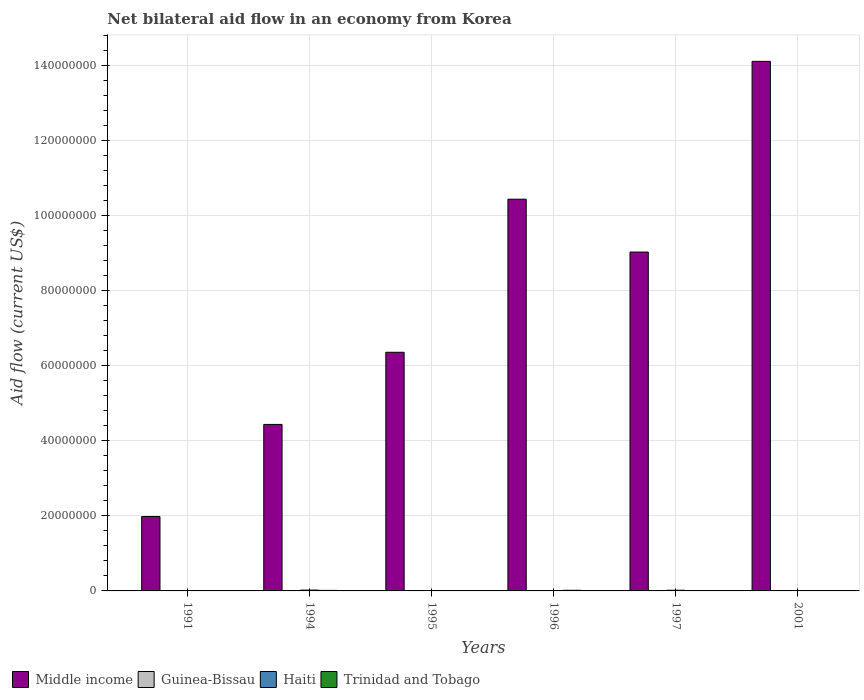How many different coloured bars are there?
Offer a terse response. 4. Are the number of bars per tick equal to the number of legend labels?
Provide a succinct answer. Yes. Are the number of bars on each tick of the X-axis equal?
Your answer should be very brief. Yes. How many bars are there on the 4th tick from the left?
Your answer should be very brief. 4. How many bars are there on the 5th tick from the right?
Offer a very short reply. 4. What is the label of the 3rd group of bars from the left?
Keep it short and to the point. 1995. In how many cases, is the number of bars for a given year not equal to the number of legend labels?
Provide a short and direct response. 0. What is the net bilateral aid flow in Middle income in 2001?
Provide a short and direct response. 1.41e+08. Across all years, what is the minimum net bilateral aid flow in Trinidad and Tobago?
Your response must be concise. 2.00e+04. In which year was the net bilateral aid flow in Middle income minimum?
Offer a terse response. 1991. What is the total net bilateral aid flow in Guinea-Bissau in the graph?
Give a very brief answer. 3.30e+05. What is the difference between the net bilateral aid flow in Trinidad and Tobago in 1994 and that in 1996?
Your response must be concise. -3.00e+04. What is the difference between the net bilateral aid flow in Middle income in 1996 and the net bilateral aid flow in Haiti in 1994?
Your answer should be very brief. 1.04e+08. What is the average net bilateral aid flow in Haiti per year?
Give a very brief answer. 1.08e+05. In the year 1991, what is the difference between the net bilateral aid flow in Middle income and net bilateral aid flow in Trinidad and Tobago?
Your answer should be compact. 1.97e+07. What is the ratio of the net bilateral aid flow in Guinea-Bissau in 1995 to that in 1996?
Your answer should be very brief. 0.62. Is the difference between the net bilateral aid flow in Middle income in 1991 and 2001 greater than the difference between the net bilateral aid flow in Trinidad and Tobago in 1991 and 2001?
Your response must be concise. No. What is the difference between the highest and the second highest net bilateral aid flow in Haiti?
Offer a very short reply. 4.00e+04. In how many years, is the net bilateral aid flow in Trinidad and Tobago greater than the average net bilateral aid flow in Trinidad and Tobago taken over all years?
Ensure brevity in your answer.  3. What does the 2nd bar from the left in 1995 represents?
Keep it short and to the point. Guinea-Bissau. What does the 2nd bar from the right in 1995 represents?
Provide a succinct answer. Haiti. How are the legend labels stacked?
Make the answer very short. Horizontal. What is the title of the graph?
Your answer should be very brief. Net bilateral aid flow in an economy from Korea. Does "Kiribati" appear as one of the legend labels in the graph?
Keep it short and to the point. No. What is the Aid flow (current US$) of Middle income in 1991?
Offer a terse response. 1.98e+07. What is the Aid flow (current US$) in Haiti in 1991?
Give a very brief answer. 10000. What is the Aid flow (current US$) in Middle income in 1994?
Offer a terse response. 4.44e+07. What is the Aid flow (current US$) in Guinea-Bissau in 1994?
Offer a very short reply. 5.00e+04. What is the Aid flow (current US$) of Trinidad and Tobago in 1994?
Provide a succinct answer. 1.40e+05. What is the Aid flow (current US$) of Middle income in 1995?
Give a very brief answer. 6.36e+07. What is the Aid flow (current US$) in Trinidad and Tobago in 1995?
Your answer should be compact. 1.00e+05. What is the Aid flow (current US$) in Middle income in 1996?
Ensure brevity in your answer.  1.04e+08. What is the Aid flow (current US$) of Guinea-Bissau in 1996?
Provide a succinct answer. 8.00e+04. What is the Aid flow (current US$) in Haiti in 1996?
Your response must be concise. 1.00e+05. What is the Aid flow (current US$) of Middle income in 1997?
Offer a very short reply. 9.03e+07. What is the Aid flow (current US$) of Trinidad and Tobago in 1997?
Provide a short and direct response. 9.00e+04. What is the Aid flow (current US$) of Middle income in 2001?
Your answer should be compact. 1.41e+08. What is the Aid flow (current US$) of Guinea-Bissau in 2001?
Offer a very short reply. 4.00e+04. Across all years, what is the maximum Aid flow (current US$) of Middle income?
Keep it short and to the point. 1.41e+08. Across all years, what is the minimum Aid flow (current US$) of Middle income?
Make the answer very short. 1.98e+07. Across all years, what is the minimum Aid flow (current US$) in Haiti?
Make the answer very short. 10000. What is the total Aid flow (current US$) in Middle income in the graph?
Offer a very short reply. 4.64e+08. What is the total Aid flow (current US$) in Guinea-Bissau in the graph?
Your response must be concise. 3.30e+05. What is the total Aid flow (current US$) in Haiti in the graph?
Your answer should be compact. 6.50e+05. What is the total Aid flow (current US$) of Trinidad and Tobago in the graph?
Ensure brevity in your answer.  6.30e+05. What is the difference between the Aid flow (current US$) of Middle income in 1991 and that in 1994?
Offer a terse response. -2.46e+07. What is the difference between the Aid flow (current US$) of Haiti in 1991 and that in 1994?
Keep it short and to the point. -2.10e+05. What is the difference between the Aid flow (current US$) in Trinidad and Tobago in 1991 and that in 1994?
Provide a succinct answer. -3.00e+04. What is the difference between the Aid flow (current US$) in Middle income in 1991 and that in 1995?
Your response must be concise. -4.38e+07. What is the difference between the Aid flow (current US$) in Guinea-Bissau in 1991 and that in 1995?
Offer a terse response. 3.00e+04. What is the difference between the Aid flow (current US$) in Trinidad and Tobago in 1991 and that in 1995?
Offer a very short reply. 10000. What is the difference between the Aid flow (current US$) in Middle income in 1991 and that in 1996?
Ensure brevity in your answer.  -8.46e+07. What is the difference between the Aid flow (current US$) in Guinea-Bissau in 1991 and that in 1996?
Provide a short and direct response. 0. What is the difference between the Aid flow (current US$) of Haiti in 1991 and that in 1996?
Provide a succinct answer. -9.00e+04. What is the difference between the Aid flow (current US$) in Trinidad and Tobago in 1991 and that in 1996?
Provide a short and direct response. -6.00e+04. What is the difference between the Aid flow (current US$) in Middle income in 1991 and that in 1997?
Give a very brief answer. -7.05e+07. What is the difference between the Aid flow (current US$) of Guinea-Bissau in 1991 and that in 1997?
Give a very brief answer. 5.00e+04. What is the difference between the Aid flow (current US$) of Middle income in 1991 and that in 2001?
Give a very brief answer. -1.21e+08. What is the difference between the Aid flow (current US$) in Guinea-Bissau in 1991 and that in 2001?
Keep it short and to the point. 4.00e+04. What is the difference between the Aid flow (current US$) in Haiti in 1991 and that in 2001?
Offer a very short reply. -3.00e+04. What is the difference between the Aid flow (current US$) of Middle income in 1994 and that in 1995?
Your answer should be compact. -1.92e+07. What is the difference between the Aid flow (current US$) of Trinidad and Tobago in 1994 and that in 1995?
Offer a very short reply. 4.00e+04. What is the difference between the Aid flow (current US$) in Middle income in 1994 and that in 1996?
Your answer should be very brief. -6.00e+07. What is the difference between the Aid flow (current US$) of Guinea-Bissau in 1994 and that in 1996?
Provide a short and direct response. -3.00e+04. What is the difference between the Aid flow (current US$) in Middle income in 1994 and that in 1997?
Make the answer very short. -4.59e+07. What is the difference between the Aid flow (current US$) in Guinea-Bissau in 1994 and that in 1997?
Your answer should be very brief. 2.00e+04. What is the difference between the Aid flow (current US$) in Trinidad and Tobago in 1994 and that in 1997?
Your answer should be very brief. 5.00e+04. What is the difference between the Aid flow (current US$) of Middle income in 1994 and that in 2001?
Provide a succinct answer. -9.68e+07. What is the difference between the Aid flow (current US$) of Haiti in 1994 and that in 2001?
Offer a very short reply. 1.80e+05. What is the difference between the Aid flow (current US$) of Middle income in 1995 and that in 1996?
Provide a succinct answer. -4.08e+07. What is the difference between the Aid flow (current US$) in Guinea-Bissau in 1995 and that in 1996?
Offer a very short reply. -3.00e+04. What is the difference between the Aid flow (current US$) in Trinidad and Tobago in 1995 and that in 1996?
Ensure brevity in your answer.  -7.00e+04. What is the difference between the Aid flow (current US$) in Middle income in 1995 and that in 1997?
Provide a short and direct response. -2.67e+07. What is the difference between the Aid flow (current US$) of Haiti in 1995 and that in 1997?
Provide a short and direct response. -8.00e+04. What is the difference between the Aid flow (current US$) in Middle income in 1995 and that in 2001?
Give a very brief answer. -7.75e+07. What is the difference between the Aid flow (current US$) of Guinea-Bissau in 1995 and that in 2001?
Offer a very short reply. 10000. What is the difference between the Aid flow (current US$) in Haiti in 1995 and that in 2001?
Make the answer very short. 6.00e+04. What is the difference between the Aid flow (current US$) in Middle income in 1996 and that in 1997?
Offer a very short reply. 1.41e+07. What is the difference between the Aid flow (current US$) of Haiti in 1996 and that in 1997?
Give a very brief answer. -8.00e+04. What is the difference between the Aid flow (current US$) of Trinidad and Tobago in 1996 and that in 1997?
Provide a short and direct response. 8.00e+04. What is the difference between the Aid flow (current US$) of Middle income in 1996 and that in 2001?
Provide a short and direct response. -3.67e+07. What is the difference between the Aid flow (current US$) in Guinea-Bissau in 1996 and that in 2001?
Offer a very short reply. 4.00e+04. What is the difference between the Aid flow (current US$) of Haiti in 1996 and that in 2001?
Provide a succinct answer. 6.00e+04. What is the difference between the Aid flow (current US$) of Trinidad and Tobago in 1996 and that in 2001?
Make the answer very short. 1.50e+05. What is the difference between the Aid flow (current US$) in Middle income in 1997 and that in 2001?
Ensure brevity in your answer.  -5.08e+07. What is the difference between the Aid flow (current US$) in Middle income in 1991 and the Aid flow (current US$) in Guinea-Bissau in 1994?
Make the answer very short. 1.98e+07. What is the difference between the Aid flow (current US$) of Middle income in 1991 and the Aid flow (current US$) of Haiti in 1994?
Make the answer very short. 1.96e+07. What is the difference between the Aid flow (current US$) of Middle income in 1991 and the Aid flow (current US$) of Trinidad and Tobago in 1994?
Your response must be concise. 1.97e+07. What is the difference between the Aid flow (current US$) of Guinea-Bissau in 1991 and the Aid flow (current US$) of Trinidad and Tobago in 1994?
Your answer should be very brief. -6.00e+04. What is the difference between the Aid flow (current US$) in Middle income in 1991 and the Aid flow (current US$) in Guinea-Bissau in 1995?
Your response must be concise. 1.98e+07. What is the difference between the Aid flow (current US$) of Middle income in 1991 and the Aid flow (current US$) of Haiti in 1995?
Make the answer very short. 1.97e+07. What is the difference between the Aid flow (current US$) of Middle income in 1991 and the Aid flow (current US$) of Trinidad and Tobago in 1995?
Your answer should be compact. 1.97e+07. What is the difference between the Aid flow (current US$) of Guinea-Bissau in 1991 and the Aid flow (current US$) of Trinidad and Tobago in 1995?
Your answer should be very brief. -2.00e+04. What is the difference between the Aid flow (current US$) in Haiti in 1991 and the Aid flow (current US$) in Trinidad and Tobago in 1995?
Provide a short and direct response. -9.00e+04. What is the difference between the Aid flow (current US$) in Middle income in 1991 and the Aid flow (current US$) in Guinea-Bissau in 1996?
Give a very brief answer. 1.98e+07. What is the difference between the Aid flow (current US$) in Middle income in 1991 and the Aid flow (current US$) in Haiti in 1996?
Make the answer very short. 1.97e+07. What is the difference between the Aid flow (current US$) in Middle income in 1991 and the Aid flow (current US$) in Trinidad and Tobago in 1996?
Offer a very short reply. 1.97e+07. What is the difference between the Aid flow (current US$) in Haiti in 1991 and the Aid flow (current US$) in Trinidad and Tobago in 1996?
Offer a very short reply. -1.60e+05. What is the difference between the Aid flow (current US$) of Middle income in 1991 and the Aid flow (current US$) of Guinea-Bissau in 1997?
Provide a succinct answer. 1.98e+07. What is the difference between the Aid flow (current US$) in Middle income in 1991 and the Aid flow (current US$) in Haiti in 1997?
Provide a short and direct response. 1.96e+07. What is the difference between the Aid flow (current US$) of Middle income in 1991 and the Aid flow (current US$) of Trinidad and Tobago in 1997?
Offer a terse response. 1.97e+07. What is the difference between the Aid flow (current US$) of Guinea-Bissau in 1991 and the Aid flow (current US$) of Haiti in 1997?
Make the answer very short. -1.00e+05. What is the difference between the Aid flow (current US$) in Middle income in 1991 and the Aid flow (current US$) in Guinea-Bissau in 2001?
Provide a short and direct response. 1.98e+07. What is the difference between the Aid flow (current US$) of Middle income in 1991 and the Aid flow (current US$) of Haiti in 2001?
Offer a terse response. 1.98e+07. What is the difference between the Aid flow (current US$) of Middle income in 1991 and the Aid flow (current US$) of Trinidad and Tobago in 2001?
Keep it short and to the point. 1.98e+07. What is the difference between the Aid flow (current US$) in Haiti in 1991 and the Aid flow (current US$) in Trinidad and Tobago in 2001?
Offer a very short reply. -10000. What is the difference between the Aid flow (current US$) of Middle income in 1994 and the Aid flow (current US$) of Guinea-Bissau in 1995?
Provide a short and direct response. 4.43e+07. What is the difference between the Aid flow (current US$) in Middle income in 1994 and the Aid flow (current US$) in Haiti in 1995?
Ensure brevity in your answer.  4.43e+07. What is the difference between the Aid flow (current US$) in Middle income in 1994 and the Aid flow (current US$) in Trinidad and Tobago in 1995?
Keep it short and to the point. 4.43e+07. What is the difference between the Aid flow (current US$) of Guinea-Bissau in 1994 and the Aid flow (current US$) of Haiti in 1995?
Your response must be concise. -5.00e+04. What is the difference between the Aid flow (current US$) of Middle income in 1994 and the Aid flow (current US$) of Guinea-Bissau in 1996?
Give a very brief answer. 4.43e+07. What is the difference between the Aid flow (current US$) in Middle income in 1994 and the Aid flow (current US$) in Haiti in 1996?
Give a very brief answer. 4.43e+07. What is the difference between the Aid flow (current US$) in Middle income in 1994 and the Aid flow (current US$) in Trinidad and Tobago in 1996?
Ensure brevity in your answer.  4.42e+07. What is the difference between the Aid flow (current US$) in Haiti in 1994 and the Aid flow (current US$) in Trinidad and Tobago in 1996?
Your answer should be very brief. 5.00e+04. What is the difference between the Aid flow (current US$) in Middle income in 1994 and the Aid flow (current US$) in Guinea-Bissau in 1997?
Offer a very short reply. 4.44e+07. What is the difference between the Aid flow (current US$) in Middle income in 1994 and the Aid flow (current US$) in Haiti in 1997?
Offer a very short reply. 4.42e+07. What is the difference between the Aid flow (current US$) of Middle income in 1994 and the Aid flow (current US$) of Trinidad and Tobago in 1997?
Your answer should be very brief. 4.43e+07. What is the difference between the Aid flow (current US$) of Haiti in 1994 and the Aid flow (current US$) of Trinidad and Tobago in 1997?
Your answer should be compact. 1.30e+05. What is the difference between the Aid flow (current US$) in Middle income in 1994 and the Aid flow (current US$) in Guinea-Bissau in 2001?
Offer a terse response. 4.43e+07. What is the difference between the Aid flow (current US$) of Middle income in 1994 and the Aid flow (current US$) of Haiti in 2001?
Keep it short and to the point. 4.43e+07. What is the difference between the Aid flow (current US$) in Middle income in 1994 and the Aid flow (current US$) in Trinidad and Tobago in 2001?
Your answer should be compact. 4.44e+07. What is the difference between the Aid flow (current US$) of Guinea-Bissau in 1994 and the Aid flow (current US$) of Trinidad and Tobago in 2001?
Provide a short and direct response. 3.00e+04. What is the difference between the Aid flow (current US$) in Middle income in 1995 and the Aid flow (current US$) in Guinea-Bissau in 1996?
Offer a very short reply. 6.35e+07. What is the difference between the Aid flow (current US$) of Middle income in 1995 and the Aid flow (current US$) of Haiti in 1996?
Offer a very short reply. 6.35e+07. What is the difference between the Aid flow (current US$) in Middle income in 1995 and the Aid flow (current US$) in Trinidad and Tobago in 1996?
Offer a very short reply. 6.34e+07. What is the difference between the Aid flow (current US$) in Guinea-Bissau in 1995 and the Aid flow (current US$) in Trinidad and Tobago in 1996?
Ensure brevity in your answer.  -1.20e+05. What is the difference between the Aid flow (current US$) of Haiti in 1995 and the Aid flow (current US$) of Trinidad and Tobago in 1996?
Make the answer very short. -7.00e+04. What is the difference between the Aid flow (current US$) in Middle income in 1995 and the Aid flow (current US$) in Guinea-Bissau in 1997?
Provide a short and direct response. 6.36e+07. What is the difference between the Aid flow (current US$) of Middle income in 1995 and the Aid flow (current US$) of Haiti in 1997?
Offer a very short reply. 6.34e+07. What is the difference between the Aid flow (current US$) in Middle income in 1995 and the Aid flow (current US$) in Trinidad and Tobago in 1997?
Offer a very short reply. 6.35e+07. What is the difference between the Aid flow (current US$) in Guinea-Bissau in 1995 and the Aid flow (current US$) in Trinidad and Tobago in 1997?
Offer a very short reply. -4.00e+04. What is the difference between the Aid flow (current US$) of Middle income in 1995 and the Aid flow (current US$) of Guinea-Bissau in 2001?
Your response must be concise. 6.36e+07. What is the difference between the Aid flow (current US$) of Middle income in 1995 and the Aid flow (current US$) of Haiti in 2001?
Your answer should be compact. 6.36e+07. What is the difference between the Aid flow (current US$) of Middle income in 1995 and the Aid flow (current US$) of Trinidad and Tobago in 2001?
Provide a short and direct response. 6.36e+07. What is the difference between the Aid flow (current US$) of Guinea-Bissau in 1995 and the Aid flow (current US$) of Trinidad and Tobago in 2001?
Provide a succinct answer. 3.00e+04. What is the difference between the Aid flow (current US$) in Middle income in 1996 and the Aid flow (current US$) in Guinea-Bissau in 1997?
Offer a terse response. 1.04e+08. What is the difference between the Aid flow (current US$) in Middle income in 1996 and the Aid flow (current US$) in Haiti in 1997?
Offer a very short reply. 1.04e+08. What is the difference between the Aid flow (current US$) in Middle income in 1996 and the Aid flow (current US$) in Trinidad and Tobago in 1997?
Provide a short and direct response. 1.04e+08. What is the difference between the Aid flow (current US$) of Guinea-Bissau in 1996 and the Aid flow (current US$) of Haiti in 1997?
Your answer should be very brief. -1.00e+05. What is the difference between the Aid flow (current US$) of Guinea-Bissau in 1996 and the Aid flow (current US$) of Trinidad and Tobago in 1997?
Provide a succinct answer. -10000. What is the difference between the Aid flow (current US$) in Haiti in 1996 and the Aid flow (current US$) in Trinidad and Tobago in 1997?
Provide a succinct answer. 10000. What is the difference between the Aid flow (current US$) in Middle income in 1996 and the Aid flow (current US$) in Guinea-Bissau in 2001?
Keep it short and to the point. 1.04e+08. What is the difference between the Aid flow (current US$) in Middle income in 1996 and the Aid flow (current US$) in Haiti in 2001?
Your answer should be very brief. 1.04e+08. What is the difference between the Aid flow (current US$) of Middle income in 1996 and the Aid flow (current US$) of Trinidad and Tobago in 2001?
Keep it short and to the point. 1.04e+08. What is the difference between the Aid flow (current US$) in Guinea-Bissau in 1996 and the Aid flow (current US$) in Haiti in 2001?
Make the answer very short. 4.00e+04. What is the difference between the Aid flow (current US$) of Guinea-Bissau in 1996 and the Aid flow (current US$) of Trinidad and Tobago in 2001?
Make the answer very short. 6.00e+04. What is the difference between the Aid flow (current US$) in Haiti in 1996 and the Aid flow (current US$) in Trinidad and Tobago in 2001?
Make the answer very short. 8.00e+04. What is the difference between the Aid flow (current US$) of Middle income in 1997 and the Aid flow (current US$) of Guinea-Bissau in 2001?
Offer a terse response. 9.03e+07. What is the difference between the Aid flow (current US$) in Middle income in 1997 and the Aid flow (current US$) in Haiti in 2001?
Ensure brevity in your answer.  9.03e+07. What is the difference between the Aid flow (current US$) in Middle income in 1997 and the Aid flow (current US$) in Trinidad and Tobago in 2001?
Provide a short and direct response. 9.03e+07. What is the difference between the Aid flow (current US$) in Guinea-Bissau in 1997 and the Aid flow (current US$) in Trinidad and Tobago in 2001?
Your answer should be very brief. 10000. What is the difference between the Aid flow (current US$) of Haiti in 1997 and the Aid flow (current US$) of Trinidad and Tobago in 2001?
Your answer should be compact. 1.60e+05. What is the average Aid flow (current US$) of Middle income per year?
Ensure brevity in your answer.  7.73e+07. What is the average Aid flow (current US$) in Guinea-Bissau per year?
Ensure brevity in your answer.  5.50e+04. What is the average Aid flow (current US$) in Haiti per year?
Offer a very short reply. 1.08e+05. What is the average Aid flow (current US$) in Trinidad and Tobago per year?
Offer a very short reply. 1.05e+05. In the year 1991, what is the difference between the Aid flow (current US$) in Middle income and Aid flow (current US$) in Guinea-Bissau?
Ensure brevity in your answer.  1.98e+07. In the year 1991, what is the difference between the Aid flow (current US$) in Middle income and Aid flow (current US$) in Haiti?
Offer a terse response. 1.98e+07. In the year 1991, what is the difference between the Aid flow (current US$) of Middle income and Aid flow (current US$) of Trinidad and Tobago?
Ensure brevity in your answer.  1.97e+07. In the year 1991, what is the difference between the Aid flow (current US$) of Guinea-Bissau and Aid flow (current US$) of Trinidad and Tobago?
Give a very brief answer. -3.00e+04. In the year 1994, what is the difference between the Aid flow (current US$) in Middle income and Aid flow (current US$) in Guinea-Bissau?
Your answer should be very brief. 4.43e+07. In the year 1994, what is the difference between the Aid flow (current US$) of Middle income and Aid flow (current US$) of Haiti?
Your response must be concise. 4.42e+07. In the year 1994, what is the difference between the Aid flow (current US$) in Middle income and Aid flow (current US$) in Trinidad and Tobago?
Ensure brevity in your answer.  4.42e+07. In the year 1994, what is the difference between the Aid flow (current US$) in Guinea-Bissau and Aid flow (current US$) in Haiti?
Keep it short and to the point. -1.70e+05. In the year 1994, what is the difference between the Aid flow (current US$) in Guinea-Bissau and Aid flow (current US$) in Trinidad and Tobago?
Provide a short and direct response. -9.00e+04. In the year 1994, what is the difference between the Aid flow (current US$) of Haiti and Aid flow (current US$) of Trinidad and Tobago?
Give a very brief answer. 8.00e+04. In the year 1995, what is the difference between the Aid flow (current US$) of Middle income and Aid flow (current US$) of Guinea-Bissau?
Provide a short and direct response. 6.36e+07. In the year 1995, what is the difference between the Aid flow (current US$) in Middle income and Aid flow (current US$) in Haiti?
Make the answer very short. 6.35e+07. In the year 1995, what is the difference between the Aid flow (current US$) in Middle income and Aid flow (current US$) in Trinidad and Tobago?
Offer a very short reply. 6.35e+07. In the year 1995, what is the difference between the Aid flow (current US$) of Guinea-Bissau and Aid flow (current US$) of Trinidad and Tobago?
Make the answer very short. -5.00e+04. In the year 1996, what is the difference between the Aid flow (current US$) of Middle income and Aid flow (current US$) of Guinea-Bissau?
Your response must be concise. 1.04e+08. In the year 1996, what is the difference between the Aid flow (current US$) of Middle income and Aid flow (current US$) of Haiti?
Keep it short and to the point. 1.04e+08. In the year 1996, what is the difference between the Aid flow (current US$) in Middle income and Aid flow (current US$) in Trinidad and Tobago?
Make the answer very short. 1.04e+08. In the year 1997, what is the difference between the Aid flow (current US$) of Middle income and Aid flow (current US$) of Guinea-Bissau?
Your answer should be compact. 9.03e+07. In the year 1997, what is the difference between the Aid flow (current US$) of Middle income and Aid flow (current US$) of Haiti?
Ensure brevity in your answer.  9.01e+07. In the year 1997, what is the difference between the Aid flow (current US$) in Middle income and Aid flow (current US$) in Trinidad and Tobago?
Ensure brevity in your answer.  9.02e+07. In the year 1997, what is the difference between the Aid flow (current US$) in Guinea-Bissau and Aid flow (current US$) in Haiti?
Give a very brief answer. -1.50e+05. In the year 1997, what is the difference between the Aid flow (current US$) in Guinea-Bissau and Aid flow (current US$) in Trinidad and Tobago?
Your answer should be compact. -6.00e+04. In the year 1997, what is the difference between the Aid flow (current US$) in Haiti and Aid flow (current US$) in Trinidad and Tobago?
Your response must be concise. 9.00e+04. In the year 2001, what is the difference between the Aid flow (current US$) in Middle income and Aid flow (current US$) in Guinea-Bissau?
Your answer should be compact. 1.41e+08. In the year 2001, what is the difference between the Aid flow (current US$) of Middle income and Aid flow (current US$) of Haiti?
Your answer should be very brief. 1.41e+08. In the year 2001, what is the difference between the Aid flow (current US$) in Middle income and Aid flow (current US$) in Trinidad and Tobago?
Provide a succinct answer. 1.41e+08. In the year 2001, what is the difference between the Aid flow (current US$) of Haiti and Aid flow (current US$) of Trinidad and Tobago?
Your answer should be very brief. 2.00e+04. What is the ratio of the Aid flow (current US$) of Middle income in 1991 to that in 1994?
Your answer should be compact. 0.45. What is the ratio of the Aid flow (current US$) of Haiti in 1991 to that in 1994?
Ensure brevity in your answer.  0.05. What is the ratio of the Aid flow (current US$) of Trinidad and Tobago in 1991 to that in 1994?
Provide a succinct answer. 0.79. What is the ratio of the Aid flow (current US$) of Middle income in 1991 to that in 1995?
Keep it short and to the point. 0.31. What is the ratio of the Aid flow (current US$) in Haiti in 1991 to that in 1995?
Provide a succinct answer. 0.1. What is the ratio of the Aid flow (current US$) of Middle income in 1991 to that in 1996?
Provide a succinct answer. 0.19. What is the ratio of the Aid flow (current US$) of Haiti in 1991 to that in 1996?
Ensure brevity in your answer.  0.1. What is the ratio of the Aid flow (current US$) in Trinidad and Tobago in 1991 to that in 1996?
Offer a very short reply. 0.65. What is the ratio of the Aid flow (current US$) in Middle income in 1991 to that in 1997?
Ensure brevity in your answer.  0.22. What is the ratio of the Aid flow (current US$) of Guinea-Bissau in 1991 to that in 1997?
Ensure brevity in your answer.  2.67. What is the ratio of the Aid flow (current US$) in Haiti in 1991 to that in 1997?
Make the answer very short. 0.06. What is the ratio of the Aid flow (current US$) of Trinidad and Tobago in 1991 to that in 1997?
Make the answer very short. 1.22. What is the ratio of the Aid flow (current US$) in Middle income in 1991 to that in 2001?
Offer a very short reply. 0.14. What is the ratio of the Aid flow (current US$) of Haiti in 1991 to that in 2001?
Offer a very short reply. 0.25. What is the ratio of the Aid flow (current US$) of Middle income in 1994 to that in 1995?
Your answer should be very brief. 0.7. What is the ratio of the Aid flow (current US$) in Middle income in 1994 to that in 1996?
Your answer should be very brief. 0.43. What is the ratio of the Aid flow (current US$) in Guinea-Bissau in 1994 to that in 1996?
Your response must be concise. 0.62. What is the ratio of the Aid flow (current US$) in Haiti in 1994 to that in 1996?
Offer a very short reply. 2.2. What is the ratio of the Aid flow (current US$) of Trinidad and Tobago in 1994 to that in 1996?
Make the answer very short. 0.82. What is the ratio of the Aid flow (current US$) in Middle income in 1994 to that in 1997?
Your response must be concise. 0.49. What is the ratio of the Aid flow (current US$) in Haiti in 1994 to that in 1997?
Offer a terse response. 1.22. What is the ratio of the Aid flow (current US$) in Trinidad and Tobago in 1994 to that in 1997?
Your answer should be compact. 1.56. What is the ratio of the Aid flow (current US$) of Middle income in 1994 to that in 2001?
Offer a very short reply. 0.31. What is the ratio of the Aid flow (current US$) of Guinea-Bissau in 1994 to that in 2001?
Keep it short and to the point. 1.25. What is the ratio of the Aid flow (current US$) in Middle income in 1995 to that in 1996?
Give a very brief answer. 0.61. What is the ratio of the Aid flow (current US$) of Guinea-Bissau in 1995 to that in 1996?
Offer a very short reply. 0.62. What is the ratio of the Aid flow (current US$) of Trinidad and Tobago in 1995 to that in 1996?
Provide a succinct answer. 0.59. What is the ratio of the Aid flow (current US$) in Middle income in 1995 to that in 1997?
Keep it short and to the point. 0.7. What is the ratio of the Aid flow (current US$) in Guinea-Bissau in 1995 to that in 1997?
Your response must be concise. 1.67. What is the ratio of the Aid flow (current US$) of Haiti in 1995 to that in 1997?
Make the answer very short. 0.56. What is the ratio of the Aid flow (current US$) in Middle income in 1995 to that in 2001?
Provide a short and direct response. 0.45. What is the ratio of the Aid flow (current US$) of Guinea-Bissau in 1995 to that in 2001?
Make the answer very short. 1.25. What is the ratio of the Aid flow (current US$) of Haiti in 1995 to that in 2001?
Offer a very short reply. 2.5. What is the ratio of the Aid flow (current US$) of Trinidad and Tobago in 1995 to that in 2001?
Your answer should be very brief. 5. What is the ratio of the Aid flow (current US$) of Middle income in 1996 to that in 1997?
Keep it short and to the point. 1.16. What is the ratio of the Aid flow (current US$) of Guinea-Bissau in 1996 to that in 1997?
Ensure brevity in your answer.  2.67. What is the ratio of the Aid flow (current US$) in Haiti in 1996 to that in 1997?
Offer a very short reply. 0.56. What is the ratio of the Aid flow (current US$) of Trinidad and Tobago in 1996 to that in 1997?
Ensure brevity in your answer.  1.89. What is the ratio of the Aid flow (current US$) in Middle income in 1996 to that in 2001?
Offer a very short reply. 0.74. What is the ratio of the Aid flow (current US$) of Guinea-Bissau in 1996 to that in 2001?
Offer a terse response. 2. What is the ratio of the Aid flow (current US$) of Haiti in 1996 to that in 2001?
Your answer should be compact. 2.5. What is the ratio of the Aid flow (current US$) of Trinidad and Tobago in 1996 to that in 2001?
Provide a short and direct response. 8.5. What is the ratio of the Aid flow (current US$) in Middle income in 1997 to that in 2001?
Your response must be concise. 0.64. What is the difference between the highest and the second highest Aid flow (current US$) in Middle income?
Make the answer very short. 3.67e+07. What is the difference between the highest and the second highest Aid flow (current US$) of Guinea-Bissau?
Provide a short and direct response. 0. What is the difference between the highest and the lowest Aid flow (current US$) of Middle income?
Your response must be concise. 1.21e+08. 